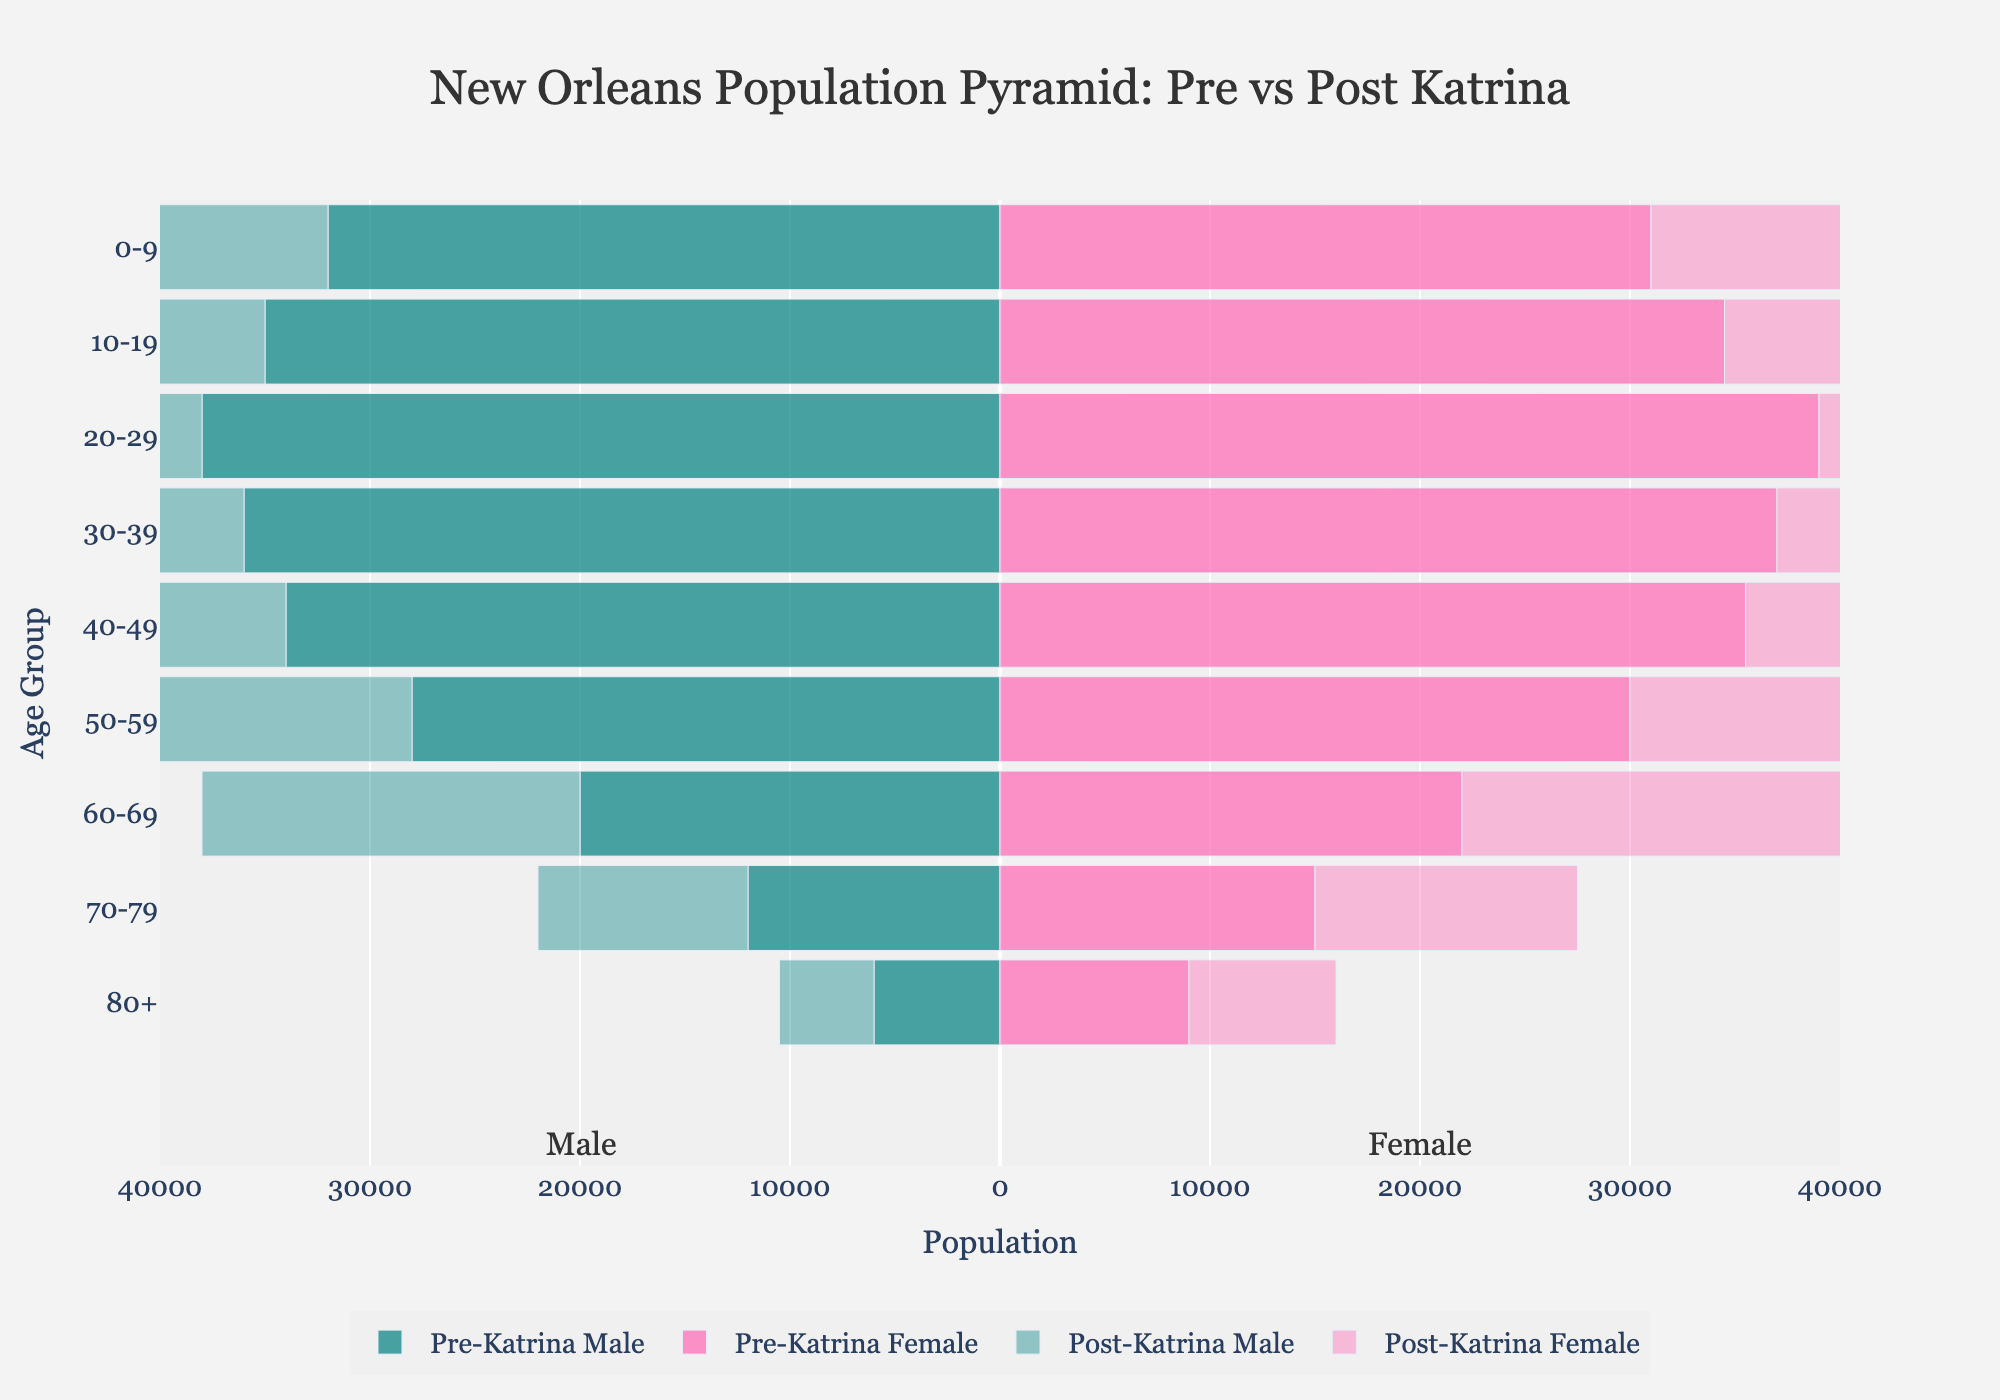What is the title of the figure? The title of the figure is usually located at the top center and summarizes the content of the figure. In this case, it reads, "New Orleans Population Pyramid: Pre vs Post Katrina."
Answer: New Orleans Population Pyramid: Pre vs Post Katrina How are the age groups labeled on the y-axis? The age groups are labeled on the y-axis using categories such as "0-9", "10-19", and so forth, up to "80+." These provide a clear breakdown of the population by age.
Answer: 0-9, 10-19, 20-29, 30-39, 40-49, 50-59, 60-69, 70-79, 80+ What colors are used to represent pre-Katrina and post-Katrina populations? The colors are used to differentiate between pre-Katrina and post-Katrina populations: pre-Katrina Male is in dark teal, Pre-Katrina Female in dark pink, post-Katrina Male in light teal, and post-Katrina Female in light pink.
Answer: Dark teal, dark pink, light teal, light pink How does the population of males aged 0-9 change from pre- to post-Katrina? First, identify the population values for this group: Pre-Katrina Male (32000) and Post-Katrina Male (21000). Find the difference by subtracting the post-Katrina population from the pre-Katrina population. 32000 - 21000 = 11000, and since the number has decreased, it's a reduction.
Answer: Decreased by 11000 Which age group experienced the smallest population decrease in males post-Katrina? Compare the population differences for each age group by subtracting post-Katrina values from pre-Katrina values: 0-9 (11000), 10-19 (11000), 20-29 (6000), 30-39 (6000), 40-49 (6000), 50-59 (3000), 60-69 (2000), 70-79 (2000), 80+ (1500). The smallest decrease is in the 80+ group.
Answer: 80+ What is the total population of females aged 50-69 pre-Katrina? Sum the population values for females in the 50-59 and 60-69 age groups pre-Katrina: 30000 + 22000. 30000 + 22000 = 52000.
Answer: 52000 Do males or females in the 20-29 age group have a larger population post-Katrina? Compare the population values for males (32000) and females (33000) in the 20-29 age group post-Katrina. Since 33000 (females) is greater than 32000 (males), females have a larger population.
Answer: Females What is the total male population pre-Katrina in the 0-39 age group? Sum the pre-Katrina male populations for age groups 0-9, 10-19, 20-29, and 30-39: 32000 + 35000 + 38000 + 36000. 32000 + 35000 + 38000 + 36000 = 141000.
Answer: 141000 How does the population trend differ between pre- and post-Katrina for the 70-79 age group? Compare the populations for males and females in the 70-79 age group pre- and post-Katrina. Pre-Katrina Male (12000), Pre-Katrina Female (15000), Post-Katrina Male (10000), Post-Katrina Female (12500). Both males and females experienced a population decrease. Males: 12000 - 10000 = 2000; Females: 15000 - 12500 = 2500.
Answer: Both decreased What is the combined population of pre-Katrina females in the 10-49 age groups? Add the pre-Katrina female populations for age groups 10-19, 20-29, 30-39, and 40-49: 34500 + 39000 + 37000 + 35500. 34500 + 39000 + 37000 + 35500 = 146000.
Answer: 146000 